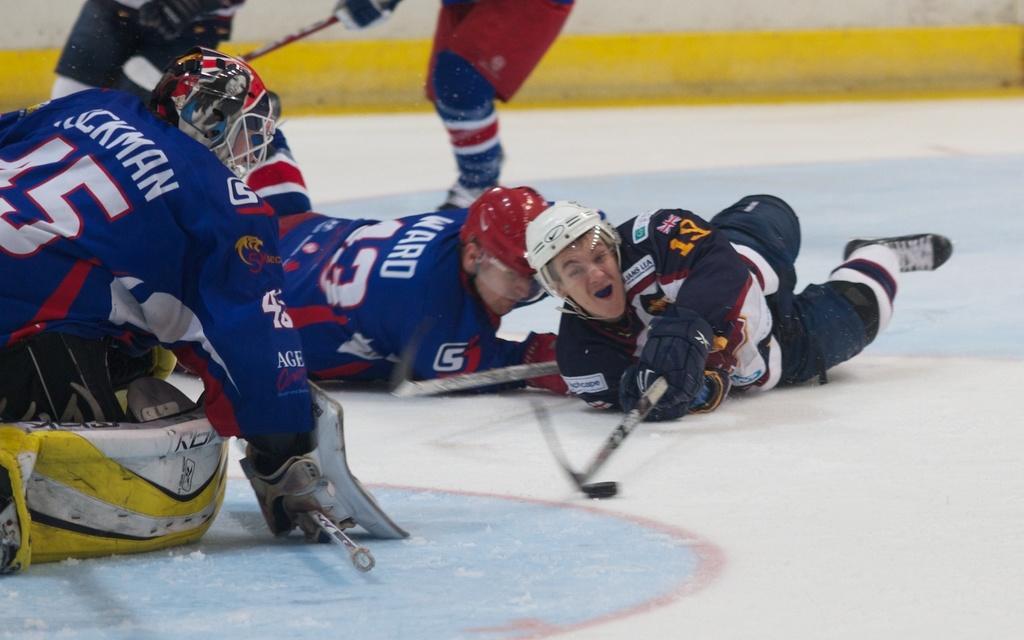Please provide a concise description of this image. In this image, we can see a few people who are wearing the same costume and are lying on the ground. They are holding hockey bats. 